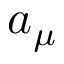Convert formula to latex. <formula><loc_0><loc_0><loc_500><loc_500>a _ { \mu }</formula> 